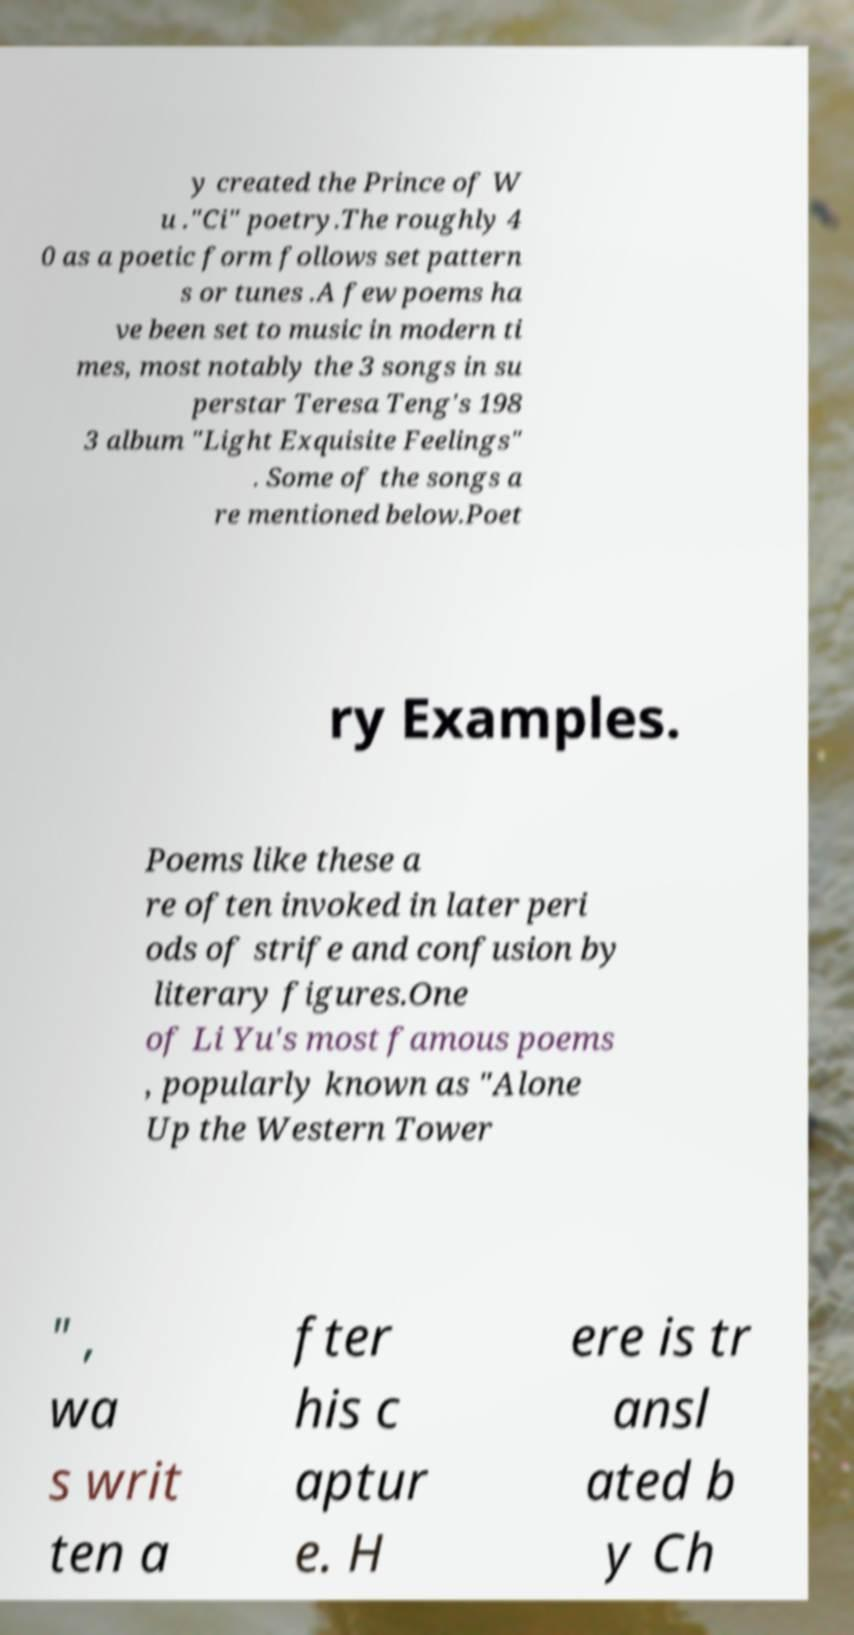Please read and relay the text visible in this image. What does it say? y created the Prince of W u ."Ci" poetry.The roughly 4 0 as a poetic form follows set pattern s or tunes .A few poems ha ve been set to music in modern ti mes, most notably the 3 songs in su perstar Teresa Teng's 198 3 album "Light Exquisite Feelings" . Some of the songs a re mentioned below.Poet ry Examples. Poems like these a re often invoked in later peri ods of strife and confusion by literary figures.One of Li Yu's most famous poems , popularly known as "Alone Up the Western Tower " , wa s writ ten a fter his c aptur e. H ere is tr ansl ated b y Ch 